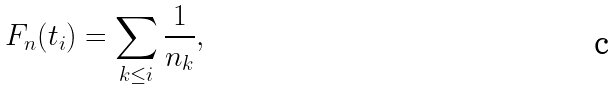<formula> <loc_0><loc_0><loc_500><loc_500>F _ { n } ( t _ { i } ) = \sum _ { k \leq i } \frac { 1 } { n _ { k } } ,</formula> 